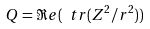<formula> <loc_0><loc_0><loc_500><loc_500>Q = \Re e ( \ t r ( Z ^ { 2 } / r ^ { 2 } ) )</formula> 